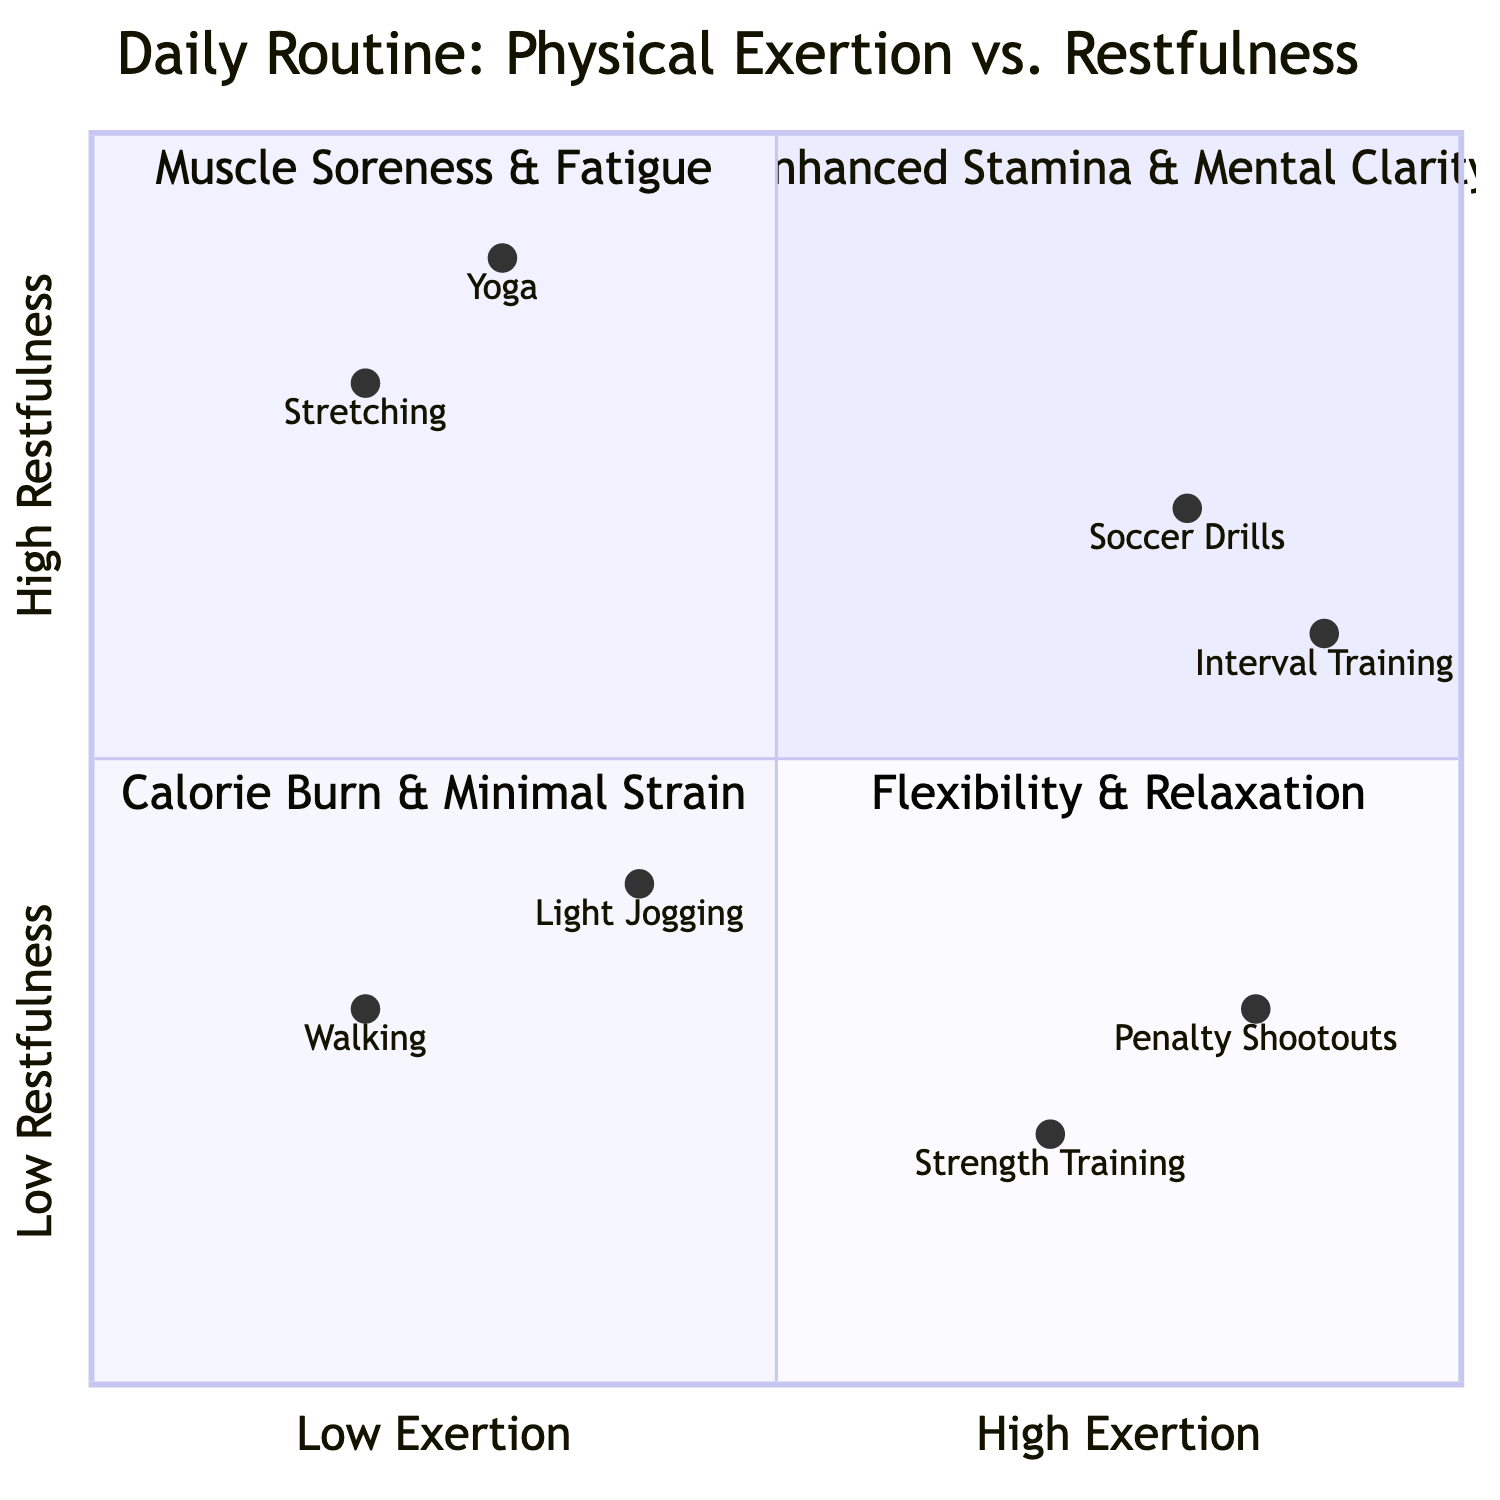What activities are in the "High Exertion, High Restfulness" quadrant? The activities listed in this quadrant are "Soccer Drills" and "Interval Training" which are shown in the top left of the diagram.
Answer: Soccer Drills, Interval Training Which quadrant contains activities that lead to "Muscle Soreness"? The quadrant labeled "High Exertion, Low Restfulness" contains activities that result in "Muscle Soreness" as indicated in the bottom left part of the diagram.
Answer: High Exertion, Low Restfulness How many activities contribute to the "Low Exertion, Low Restfulness" quadrant? There are two activities in this quadrant: "Light Jogging" and "Walking", which are present in the bottom right section of the diagram.
Answer: 2 What is the primary benefit of "Stretching Exercises"? Within the "Low Exertion, High Restfulness" quadrant, the main benefit attributed to "Stretching Exercises" is "Flexibility Improvement," as noted in the top right part of the diagram.
Answer: Flexibility Improvement Which activity has the lowest "Restfulness" level? "Strength Training" has the lowest Restfulness level of 0.2, which is shown in the "High Exertion, Low Restfulness" quadrant.
Answer: Strength Training What do "Penalty Shootouts Practice" and "Strength Training" have in common? Both activities are found in the "High Exertion, Low Restfulness" quadrant, indicating they share similar exertional characteristics and result in effects such as "Muscle Soreness."
Answer: Both are high exertion activities Which quadrant has activities primarily aimed at relaxation? The "Low Exertion, High Restfulness" quadrant focuses on relaxation activities like "Stretching Exercises" and "Yoga Sessions,” located in the top right of the diagram.
Answer: Low Exertion, High Restfulness What are the effects of activities in the "Low Exertion, Low Restfulness" quadrant? The effects listed under this quadrant are "Calorie Burn" and "Minimal Muscle Strain," indicating a balance of low exertion and low restfulness shown in the bottom right section.
Answer: Calorie Burn, Minimal Muscle Strain Which activity scored the highest in the exertion axis? "Interval Training" scored the highest with a value of 0.9 on the exertion axis, positioning it near the top of the exertion scale in the diagram.
Answer: Interval Training 